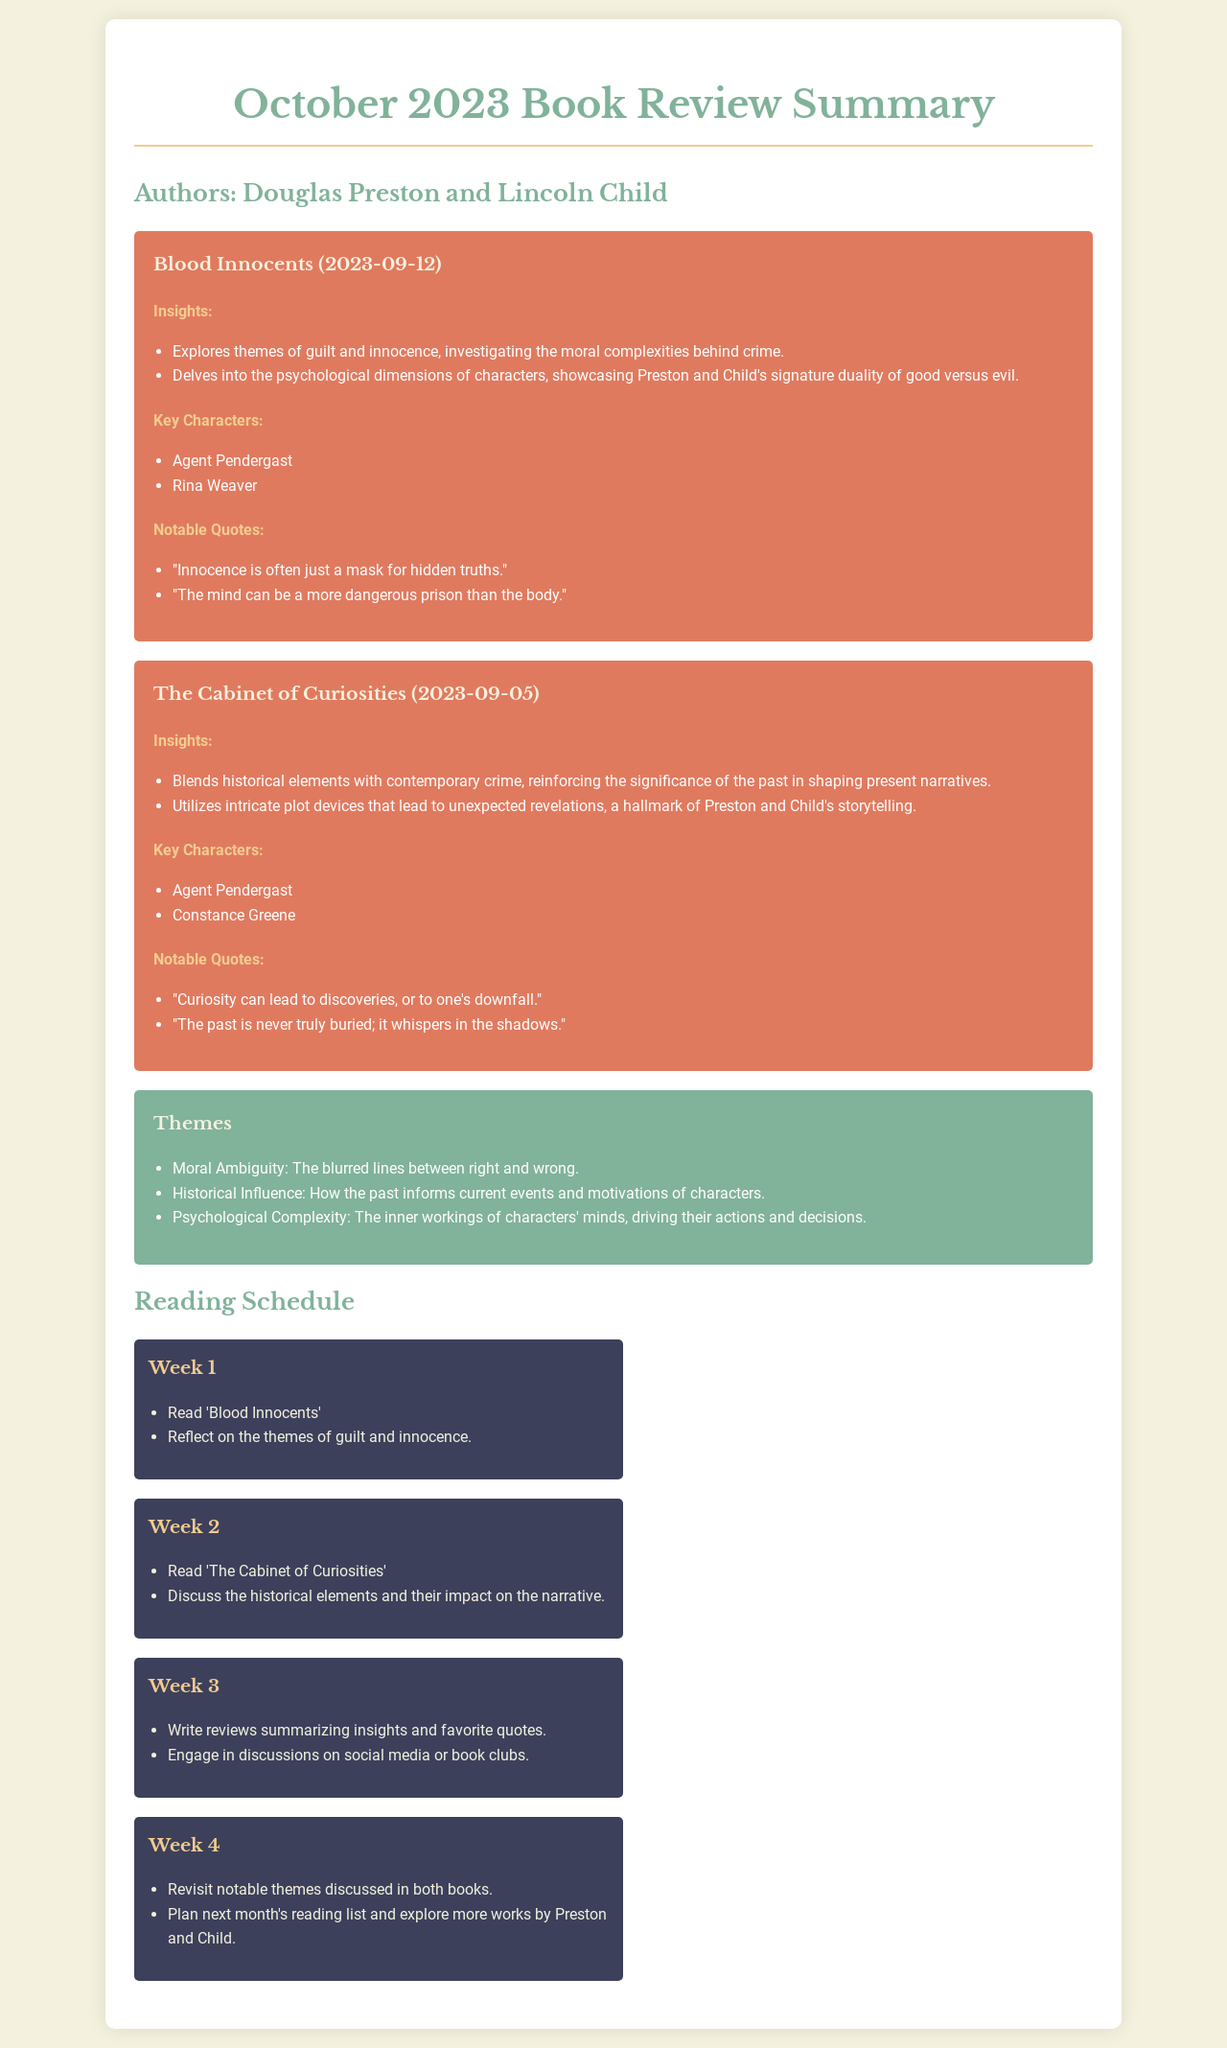What is the title of the first book reviewed? The first book listed in the document is titled "Blood Innocents."
Answer: Blood Innocents Who are the authors of the reviewed books? The document states that the authors are Douglas Preston and Lincoln Child.
Answer: Douglas Preston and Lincoln Child When was "The Cabinet of Curiosities" published? The publication date for "The Cabinet of Curiosities" is provided as September 5, 2023.
Answer: 2023-09-05 What is one of the key themes highlighted in the document? The document lists several themes, one of which is "Moral Ambiguity."
Answer: Moral Ambiguity What notable quote is attributed to "Blood Innocents"? A notable quote from "Blood Innocents" is mentioned in the insights section.
Answer: "The mind can be a more dangerous prison than the body." What should be discussed in Week 2 of the reading schedule? Week 2 focuses on discussing the historical elements and their impact on the narrative.
Answer: Discuss the historical elements and their impact on the narrative How many weeks are included in the reading schedule? The reading schedule is divided into four weeks.
Answer: 4 Which character appears in both reviewed books? The key character that appears in both "Blood Innocents" and "The Cabinet of Curiosities" is mentioned.
Answer: Agent Pendergast 